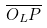Convert formula to latex. <formula><loc_0><loc_0><loc_500><loc_500>\overline { O _ { L } P }</formula> 